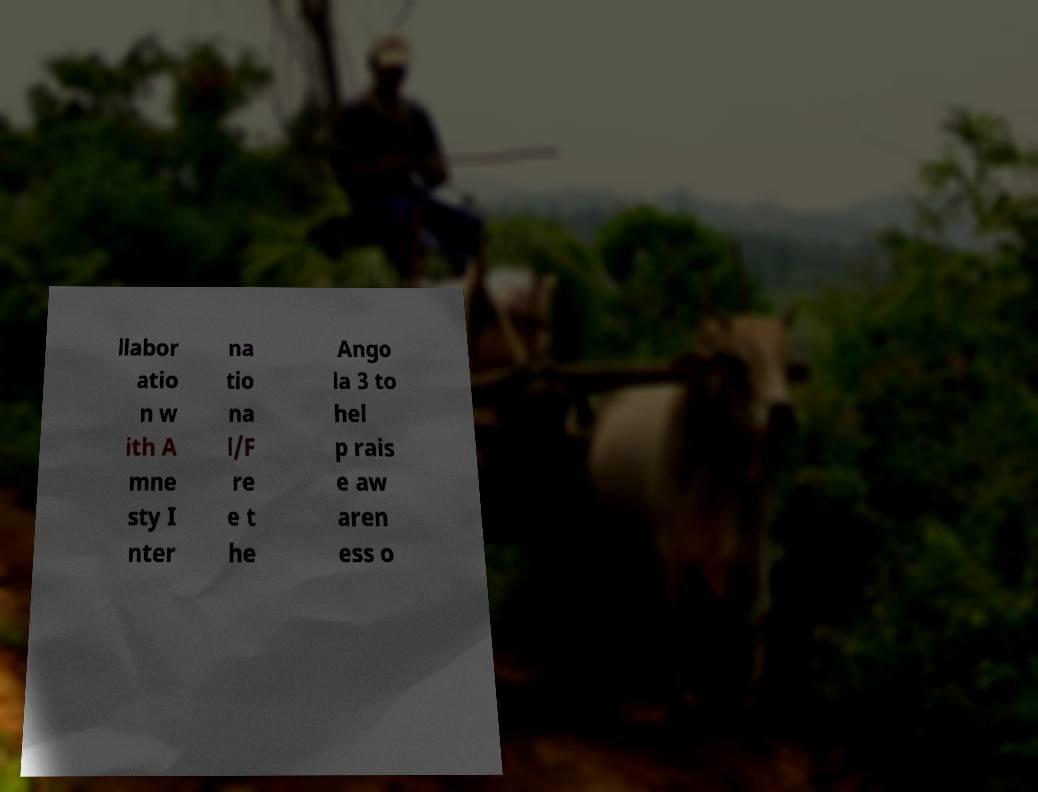I need the written content from this picture converted into text. Can you do that? llabor atio n w ith A mne sty I nter na tio na l/F re e t he Ango la 3 to hel p rais e aw aren ess o 